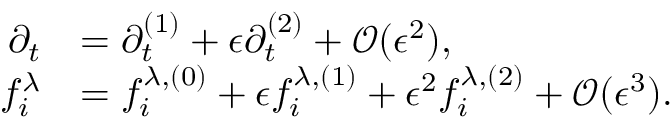Convert formula to latex. <formula><loc_0><loc_0><loc_500><loc_500>\begin{array} { r l } { \partial _ { t } } & { = \partial _ { t } ^ { ( 1 ) } + \epsilon \partial _ { t } ^ { ( 2 ) } + \mathcal { O } ( \epsilon ^ { 2 } ) , } \\ { f _ { i } ^ { \lambda } } & { = f _ { i } ^ { \lambda , ( 0 ) } + \epsilon f _ { i } ^ { \lambda , ( 1 ) } + \epsilon ^ { 2 } f _ { i } ^ { \lambda , ( 2 ) } + \mathcal { O } ( \epsilon ^ { 3 } ) . } \end{array}</formula> 